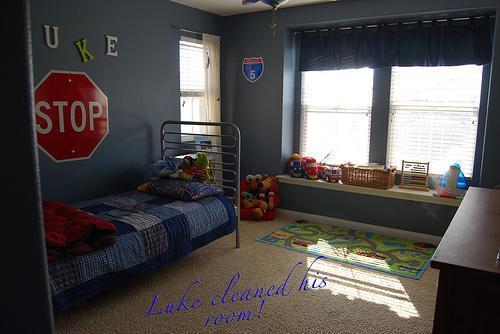How many rugs are in the picture?
Give a very brief answer. 1. 